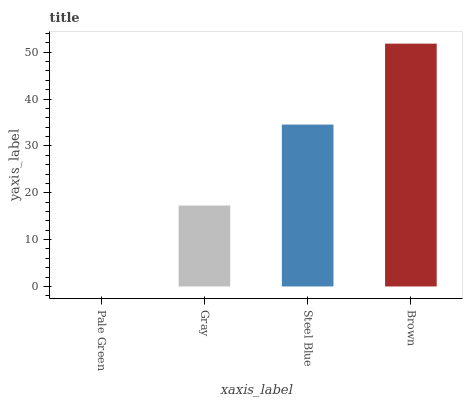Is Gray the minimum?
Answer yes or no. No. Is Gray the maximum?
Answer yes or no. No. Is Gray greater than Pale Green?
Answer yes or no. Yes. Is Pale Green less than Gray?
Answer yes or no. Yes. Is Pale Green greater than Gray?
Answer yes or no. No. Is Gray less than Pale Green?
Answer yes or no. No. Is Steel Blue the high median?
Answer yes or no. Yes. Is Gray the low median?
Answer yes or no. Yes. Is Gray the high median?
Answer yes or no. No. Is Steel Blue the low median?
Answer yes or no. No. 